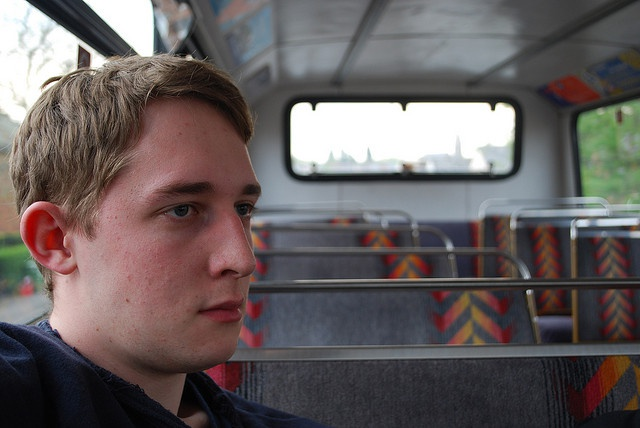Describe the objects in this image and their specific colors. I can see bus in white, gray, black, and darkgray tones, people in white, black, brown, and maroon tones, chair in white, gray, black, and maroon tones, chair in white, black, maroon, and gray tones, and chair in white, gray, black, and maroon tones in this image. 